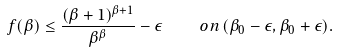Convert formula to latex. <formula><loc_0><loc_0><loc_500><loc_500>f ( \beta ) \leq \frac { ( \beta + 1 ) ^ { \beta + 1 } } { \beta ^ { \beta } } - \epsilon \quad o n \, ( \beta _ { 0 } - \epsilon , \beta _ { 0 } + \epsilon ) .</formula> 